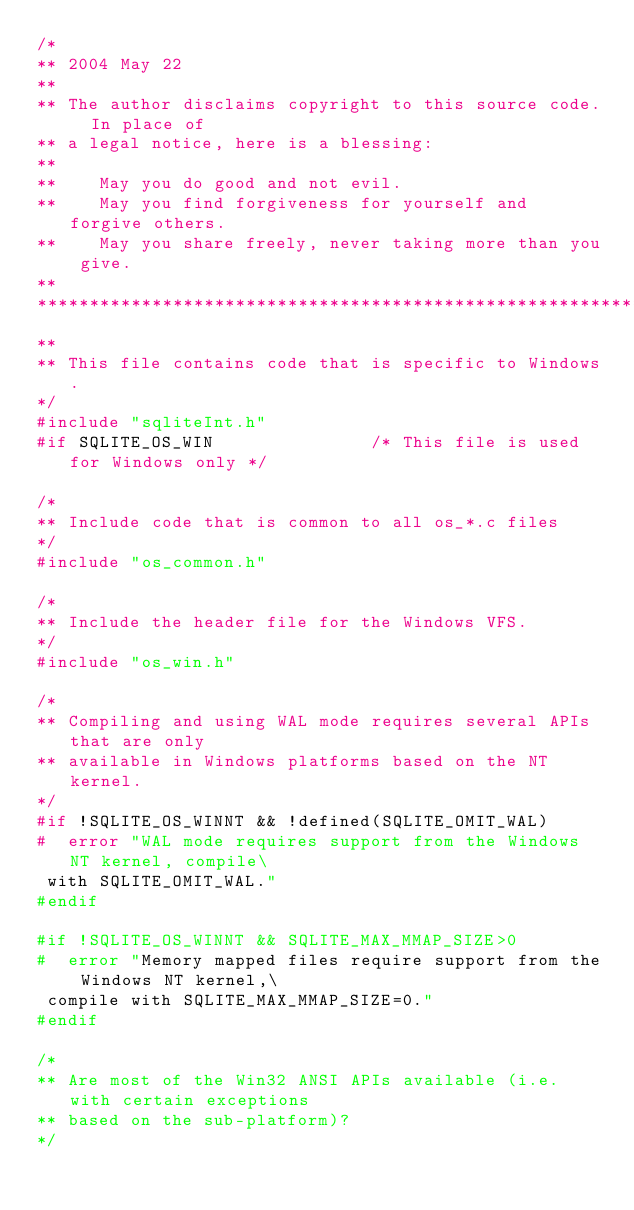<code> <loc_0><loc_0><loc_500><loc_500><_C_>/*
** 2004 May 22
**
** The author disclaims copyright to this source code.  In place of
** a legal notice, here is a blessing:
**
**    May you do good and not evil.
**    May you find forgiveness for yourself and forgive others.
**    May you share freely, never taking more than you give.
**
******************************************************************************
**
** This file contains code that is specific to Windows.
*/
#include "sqliteInt.h"
#if SQLITE_OS_WIN               /* This file is used for Windows only */

/*
** Include code that is common to all os_*.c files
*/
#include "os_common.h"

/*
** Include the header file for the Windows VFS.
*/
#include "os_win.h"

/*
** Compiling and using WAL mode requires several APIs that are only
** available in Windows platforms based on the NT kernel.
*/
#if !SQLITE_OS_WINNT && !defined(SQLITE_OMIT_WAL)
#  error "WAL mode requires support from the Windows NT kernel, compile\
 with SQLITE_OMIT_WAL."
#endif

#if !SQLITE_OS_WINNT && SQLITE_MAX_MMAP_SIZE>0
#  error "Memory mapped files require support from the Windows NT kernel,\
 compile with SQLITE_MAX_MMAP_SIZE=0."
#endif

/*
** Are most of the Win32 ANSI APIs available (i.e. with certain exceptions
** based on the sub-platform)?
*/</code> 